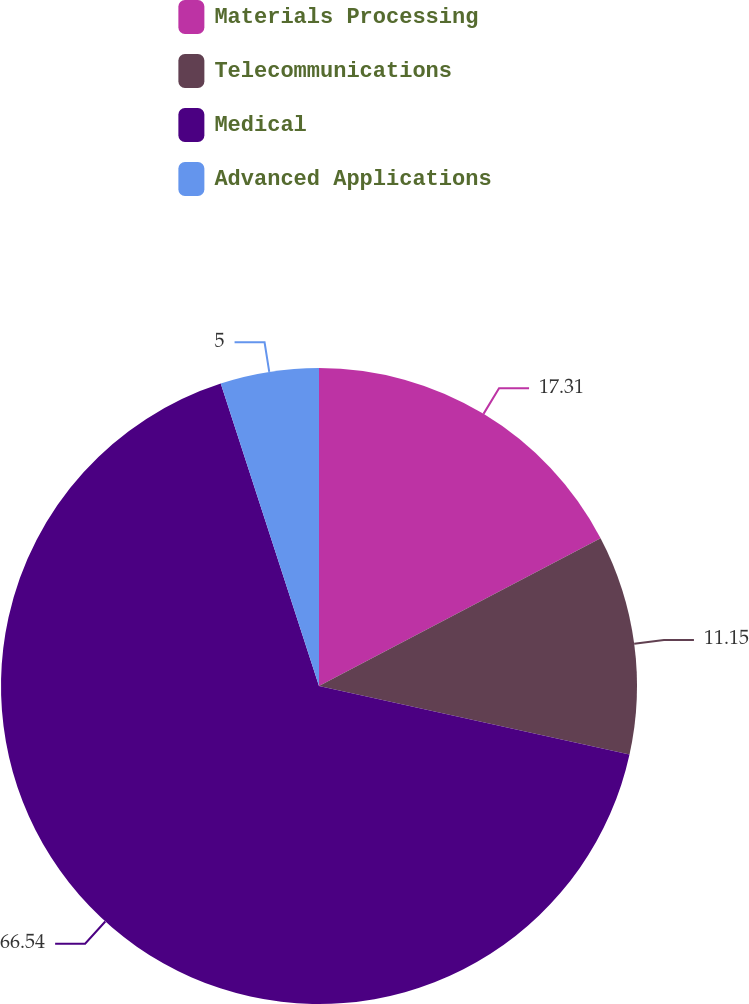<chart> <loc_0><loc_0><loc_500><loc_500><pie_chart><fcel>Materials Processing<fcel>Telecommunications<fcel>Medical<fcel>Advanced Applications<nl><fcel>17.31%<fcel>11.15%<fcel>66.54%<fcel>5.0%<nl></chart> 